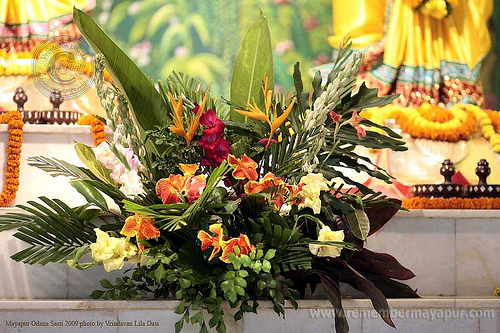<image>Do these flowers have a scent? I'm not sure if these flowers have a scent, it's something that can't be determined visually. Do these flowers have a scent? I don't know if these flowers have a scent. It is possible that they do. 